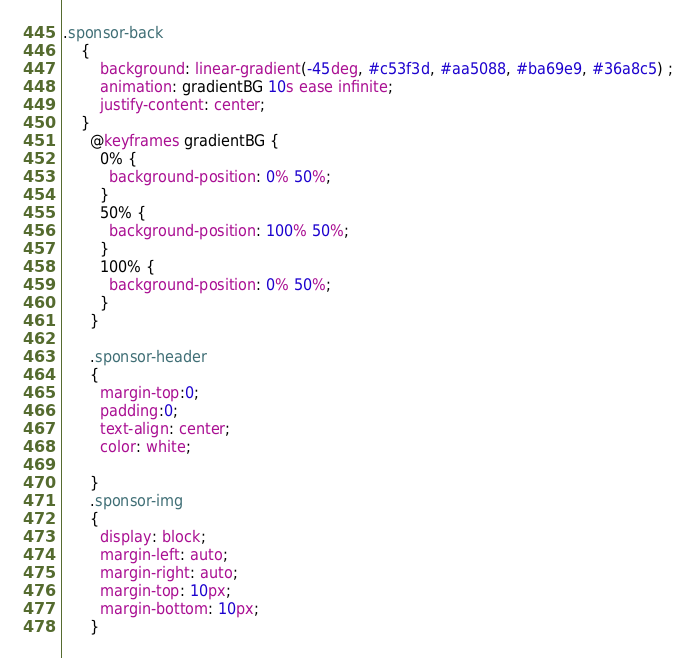Convert code to text. <code><loc_0><loc_0><loc_500><loc_500><_CSS_>.sponsor-back
    {
        background: linear-gradient(-45deg, #c53f3d, #aa5088, #ba69e9, #36a8c5) ;
        animation: gradientBG 10s ease infinite;
        justify-content: center;
    }
      @keyframes gradientBG {
        0% {
          background-position: 0% 50%;
        }
        50% {
          background-position: 100% 50%;
        }
        100% {
          background-position: 0% 50%;
        }
      }
    
      .sponsor-header
      {
        margin-top:0;
        padding:0;
        text-align: center;
        color: white;
        
      }
      .sponsor-img
      {
        display: block;
        margin-left: auto;
        margin-right: auto;
        margin-top: 10px;
        margin-bottom: 10px;
      }</code> 